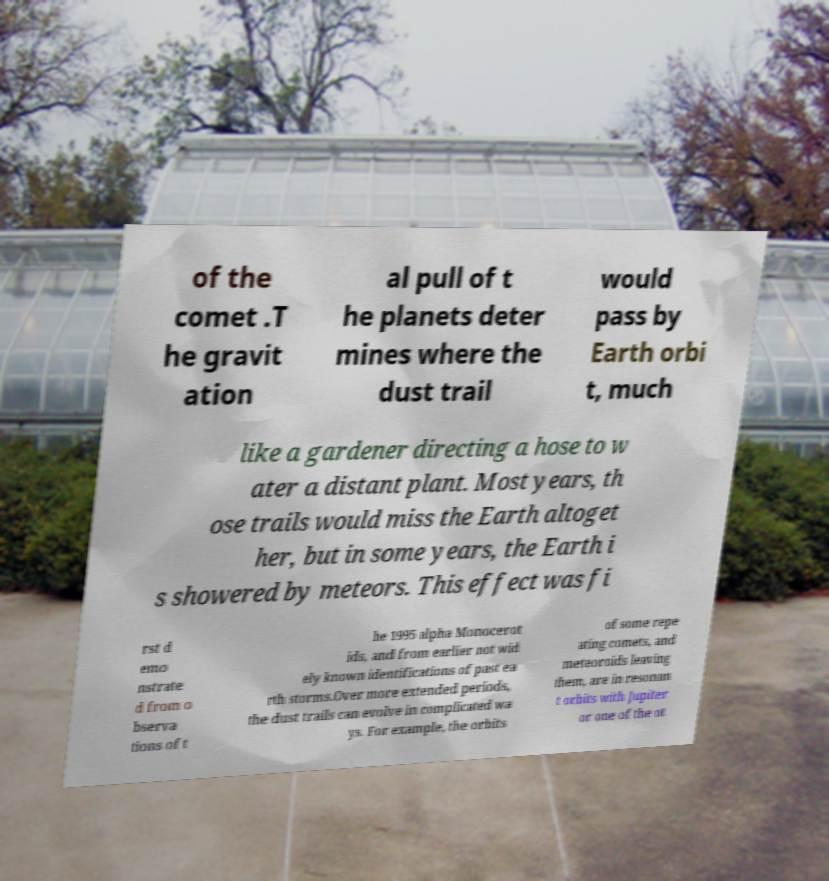Could you assist in decoding the text presented in this image and type it out clearly? of the comet .T he gravit ation al pull of t he planets deter mines where the dust trail would pass by Earth orbi t, much like a gardener directing a hose to w ater a distant plant. Most years, th ose trails would miss the Earth altoget her, but in some years, the Earth i s showered by meteors. This effect was fi rst d emo nstrate d from o bserva tions of t he 1995 alpha Monocerot ids, and from earlier not wid ely known identifications of past ea rth storms.Over more extended periods, the dust trails can evolve in complicated wa ys. For example, the orbits of some repe ating comets, and meteoroids leaving them, are in resonan t orbits with Jupiter or one of the ot 